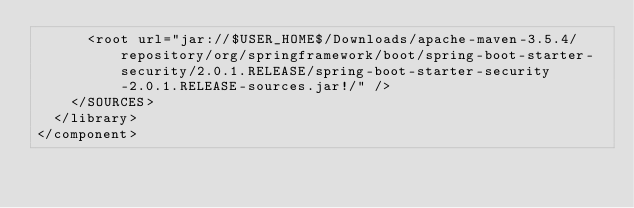Convert code to text. <code><loc_0><loc_0><loc_500><loc_500><_XML_>      <root url="jar://$USER_HOME$/Downloads/apache-maven-3.5.4/repository/org/springframework/boot/spring-boot-starter-security/2.0.1.RELEASE/spring-boot-starter-security-2.0.1.RELEASE-sources.jar!/" />
    </SOURCES>
  </library>
</component></code> 